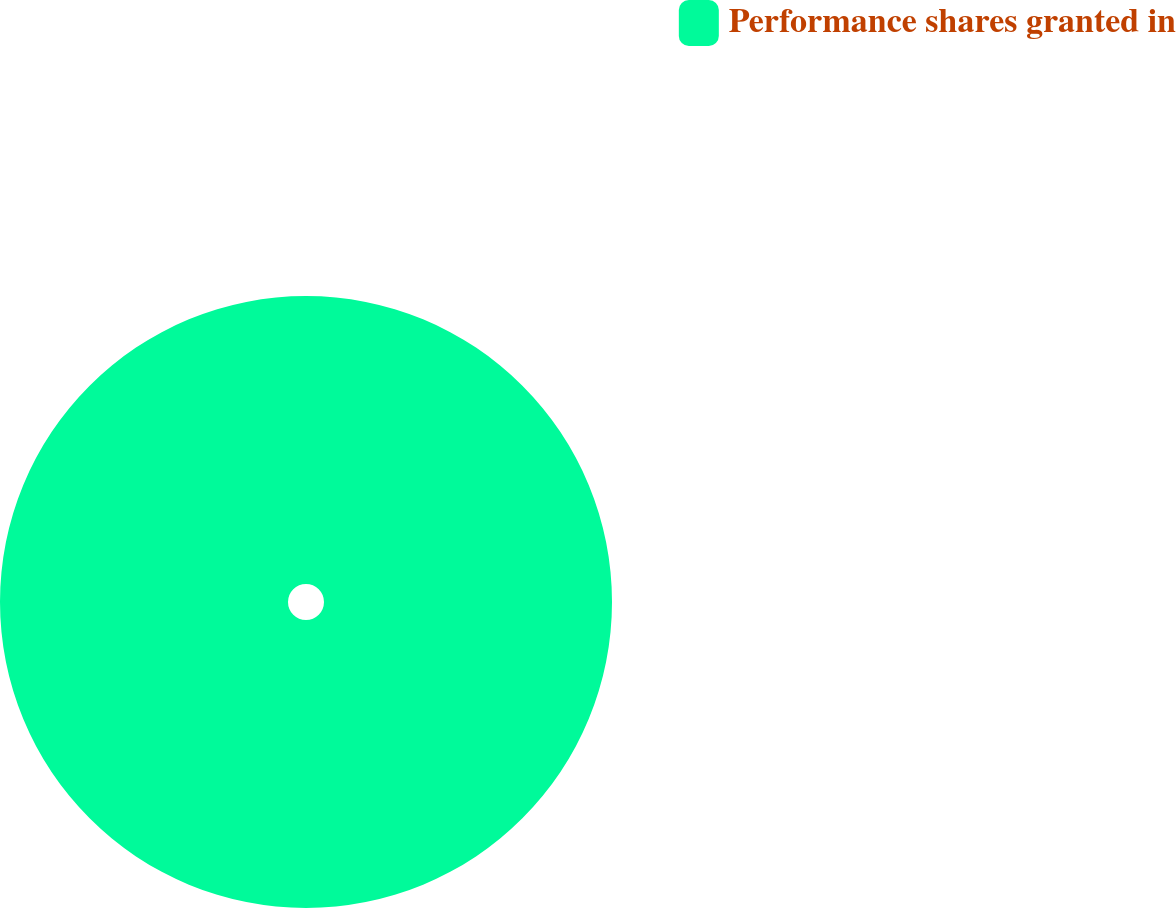Convert chart. <chart><loc_0><loc_0><loc_500><loc_500><pie_chart><fcel>Performance shares granted in<nl><fcel>100.0%<nl></chart> 